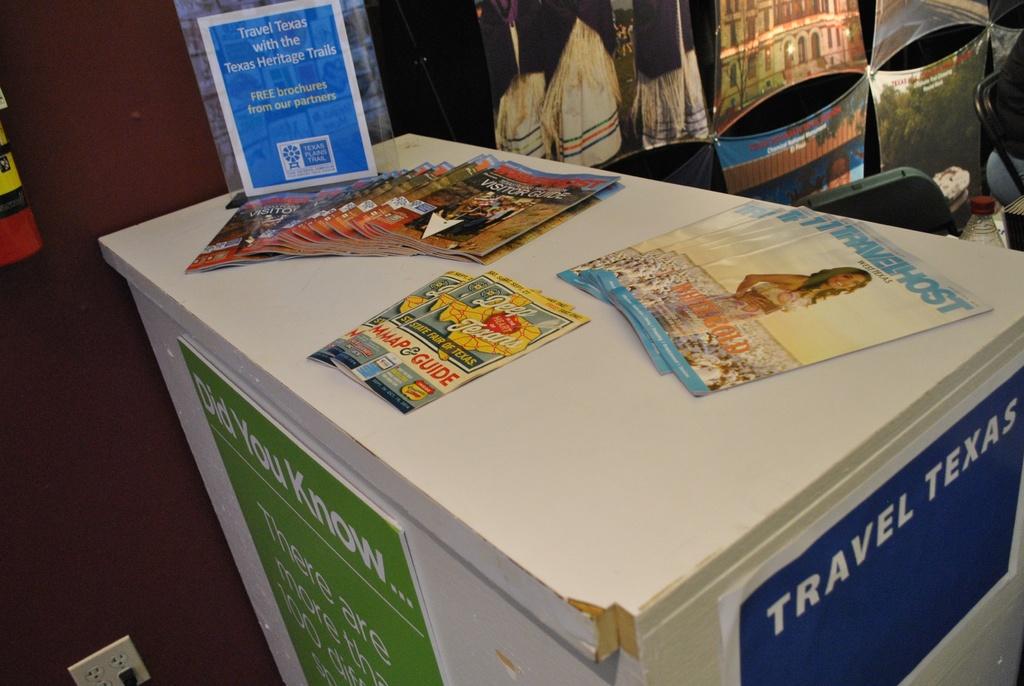What state is advertised?
Make the answer very short. Texas. 